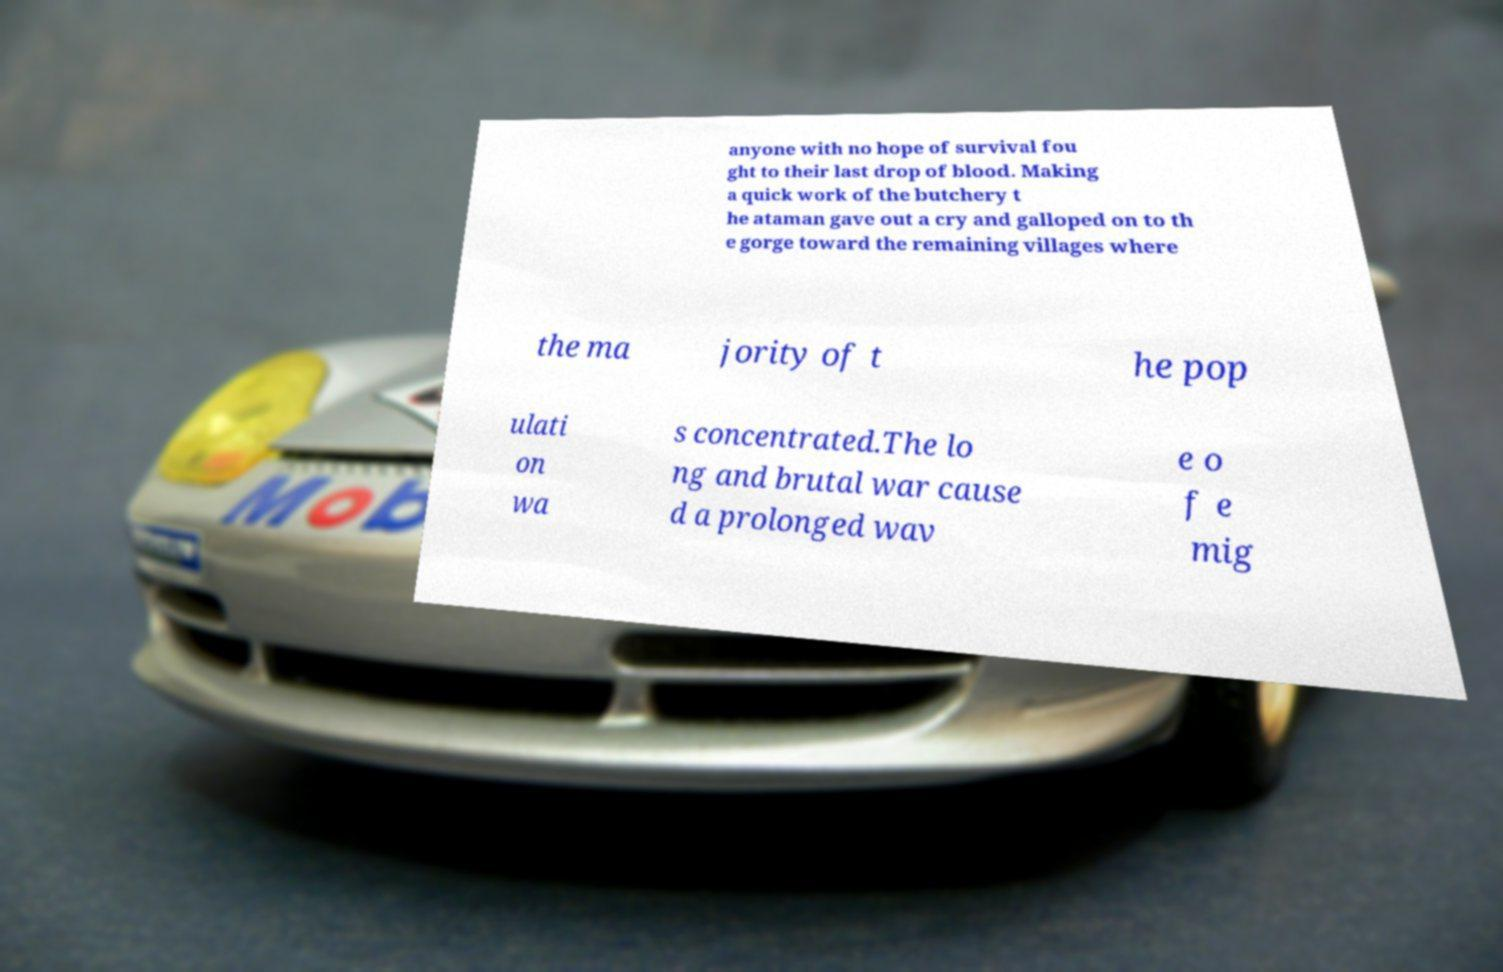Can you accurately transcribe the text from the provided image for me? anyone with no hope of survival fou ght to their last drop of blood. Making a quick work of the butchery t he ataman gave out a cry and galloped on to th e gorge toward the remaining villages where the ma jority of t he pop ulati on wa s concentrated.The lo ng and brutal war cause d a prolonged wav e o f e mig 